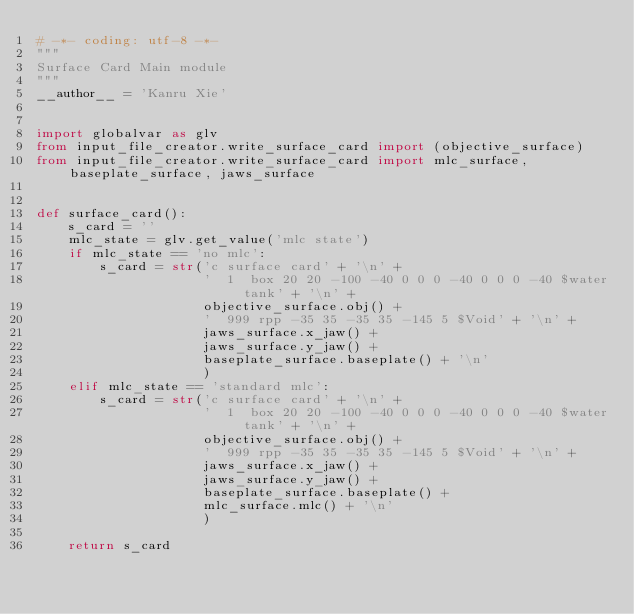<code> <loc_0><loc_0><loc_500><loc_500><_Python_># -*- coding: utf-8 -*-
"""
Surface Card Main module
"""
__author__ = 'Kanru Xie'


import globalvar as glv
from input_file_creator.write_surface_card import (objective_surface)
from input_file_creator.write_surface_card import mlc_surface, baseplate_surface, jaws_surface


def surface_card():
    s_card = ''
    mlc_state = glv.get_value('mlc state')
    if mlc_state == 'no mlc':
        s_card = str('c surface card' + '\n' +
                     '  1  box 20 20 -100 -40 0 0 0 -40 0 0 0 -40 $water tank' + '\n' +
                     objective_surface.obj() +
                     '  999 rpp -35 35 -35 35 -145 5 $Void' + '\n' +
                     jaws_surface.x_jaw() +
                     jaws_surface.y_jaw() +
                     baseplate_surface.baseplate() + '\n'
                     )
    elif mlc_state == 'standard mlc':
        s_card = str('c surface card' + '\n' +
                     '  1  box 20 20 -100 -40 0 0 0 -40 0 0 0 -40 $water tank' + '\n' +
                     objective_surface.obj() +
                     '  999 rpp -35 35 -35 35 -145 5 $Void' + '\n' +
                     jaws_surface.x_jaw() +
                     jaws_surface.y_jaw() +
                     baseplate_surface.baseplate() +
                     mlc_surface.mlc() + '\n'
                     )

    return s_card
</code> 